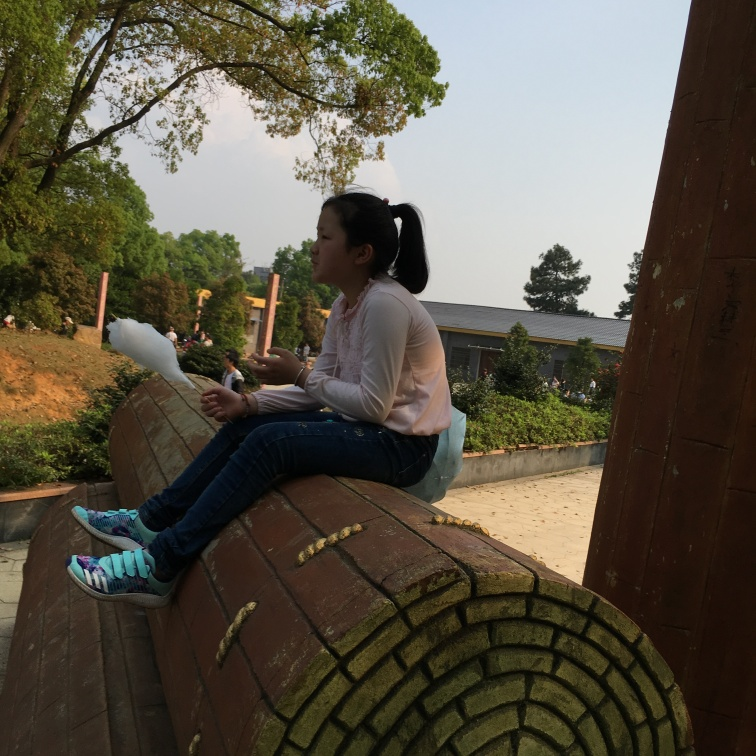Can you describe the setting of this image? The image features an outdoor setting with a clear, bright sky. The subject is seated on a textured, curved architecture, which could be part of a park or a public recreational area. In the background, there's an array of greenery and a patch of buildings that suggest this place might be within a community space or near institutional buildings. 